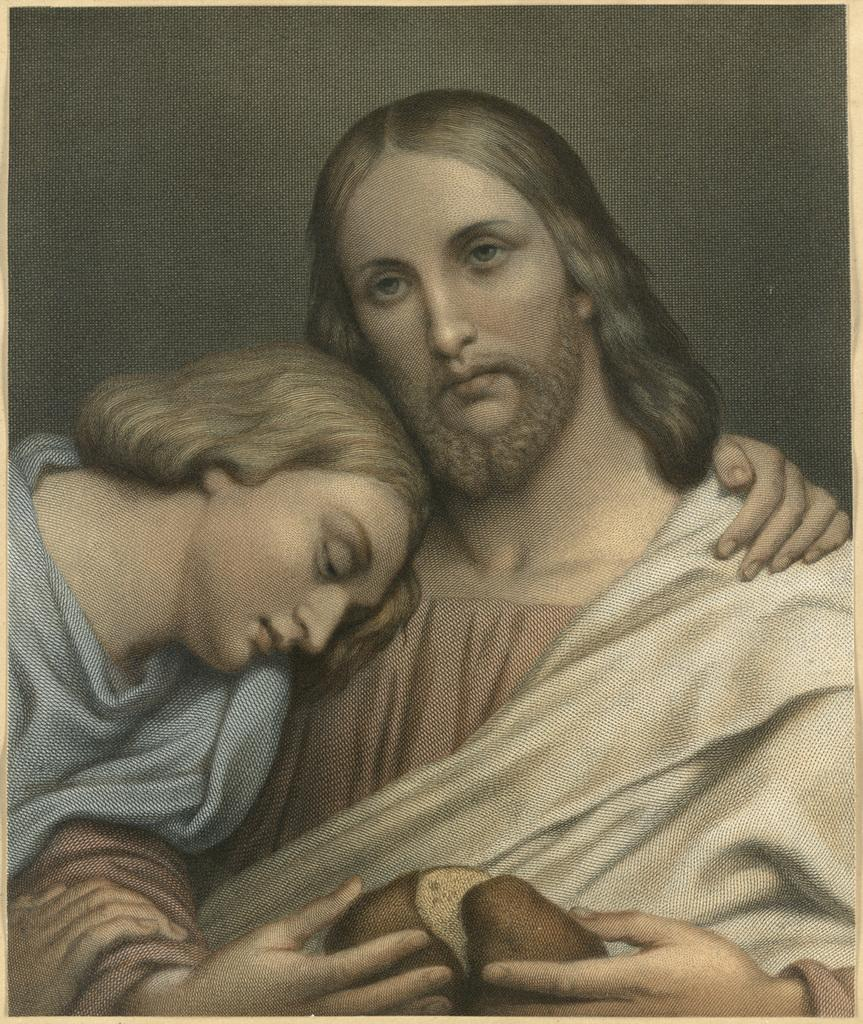How many people are present in the image? There are two people in the image, a woman and a man. What type of oatmeal is the woman eating in the image? There is no oatmeal present in the image, and the woman is not eating anything. Can you tell me how the boat is being used in the image? There is no boat present in the image, so it cannot be used for any purpose. 